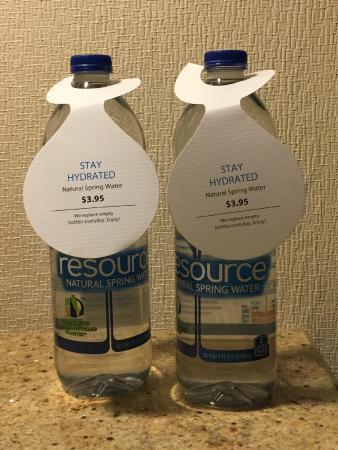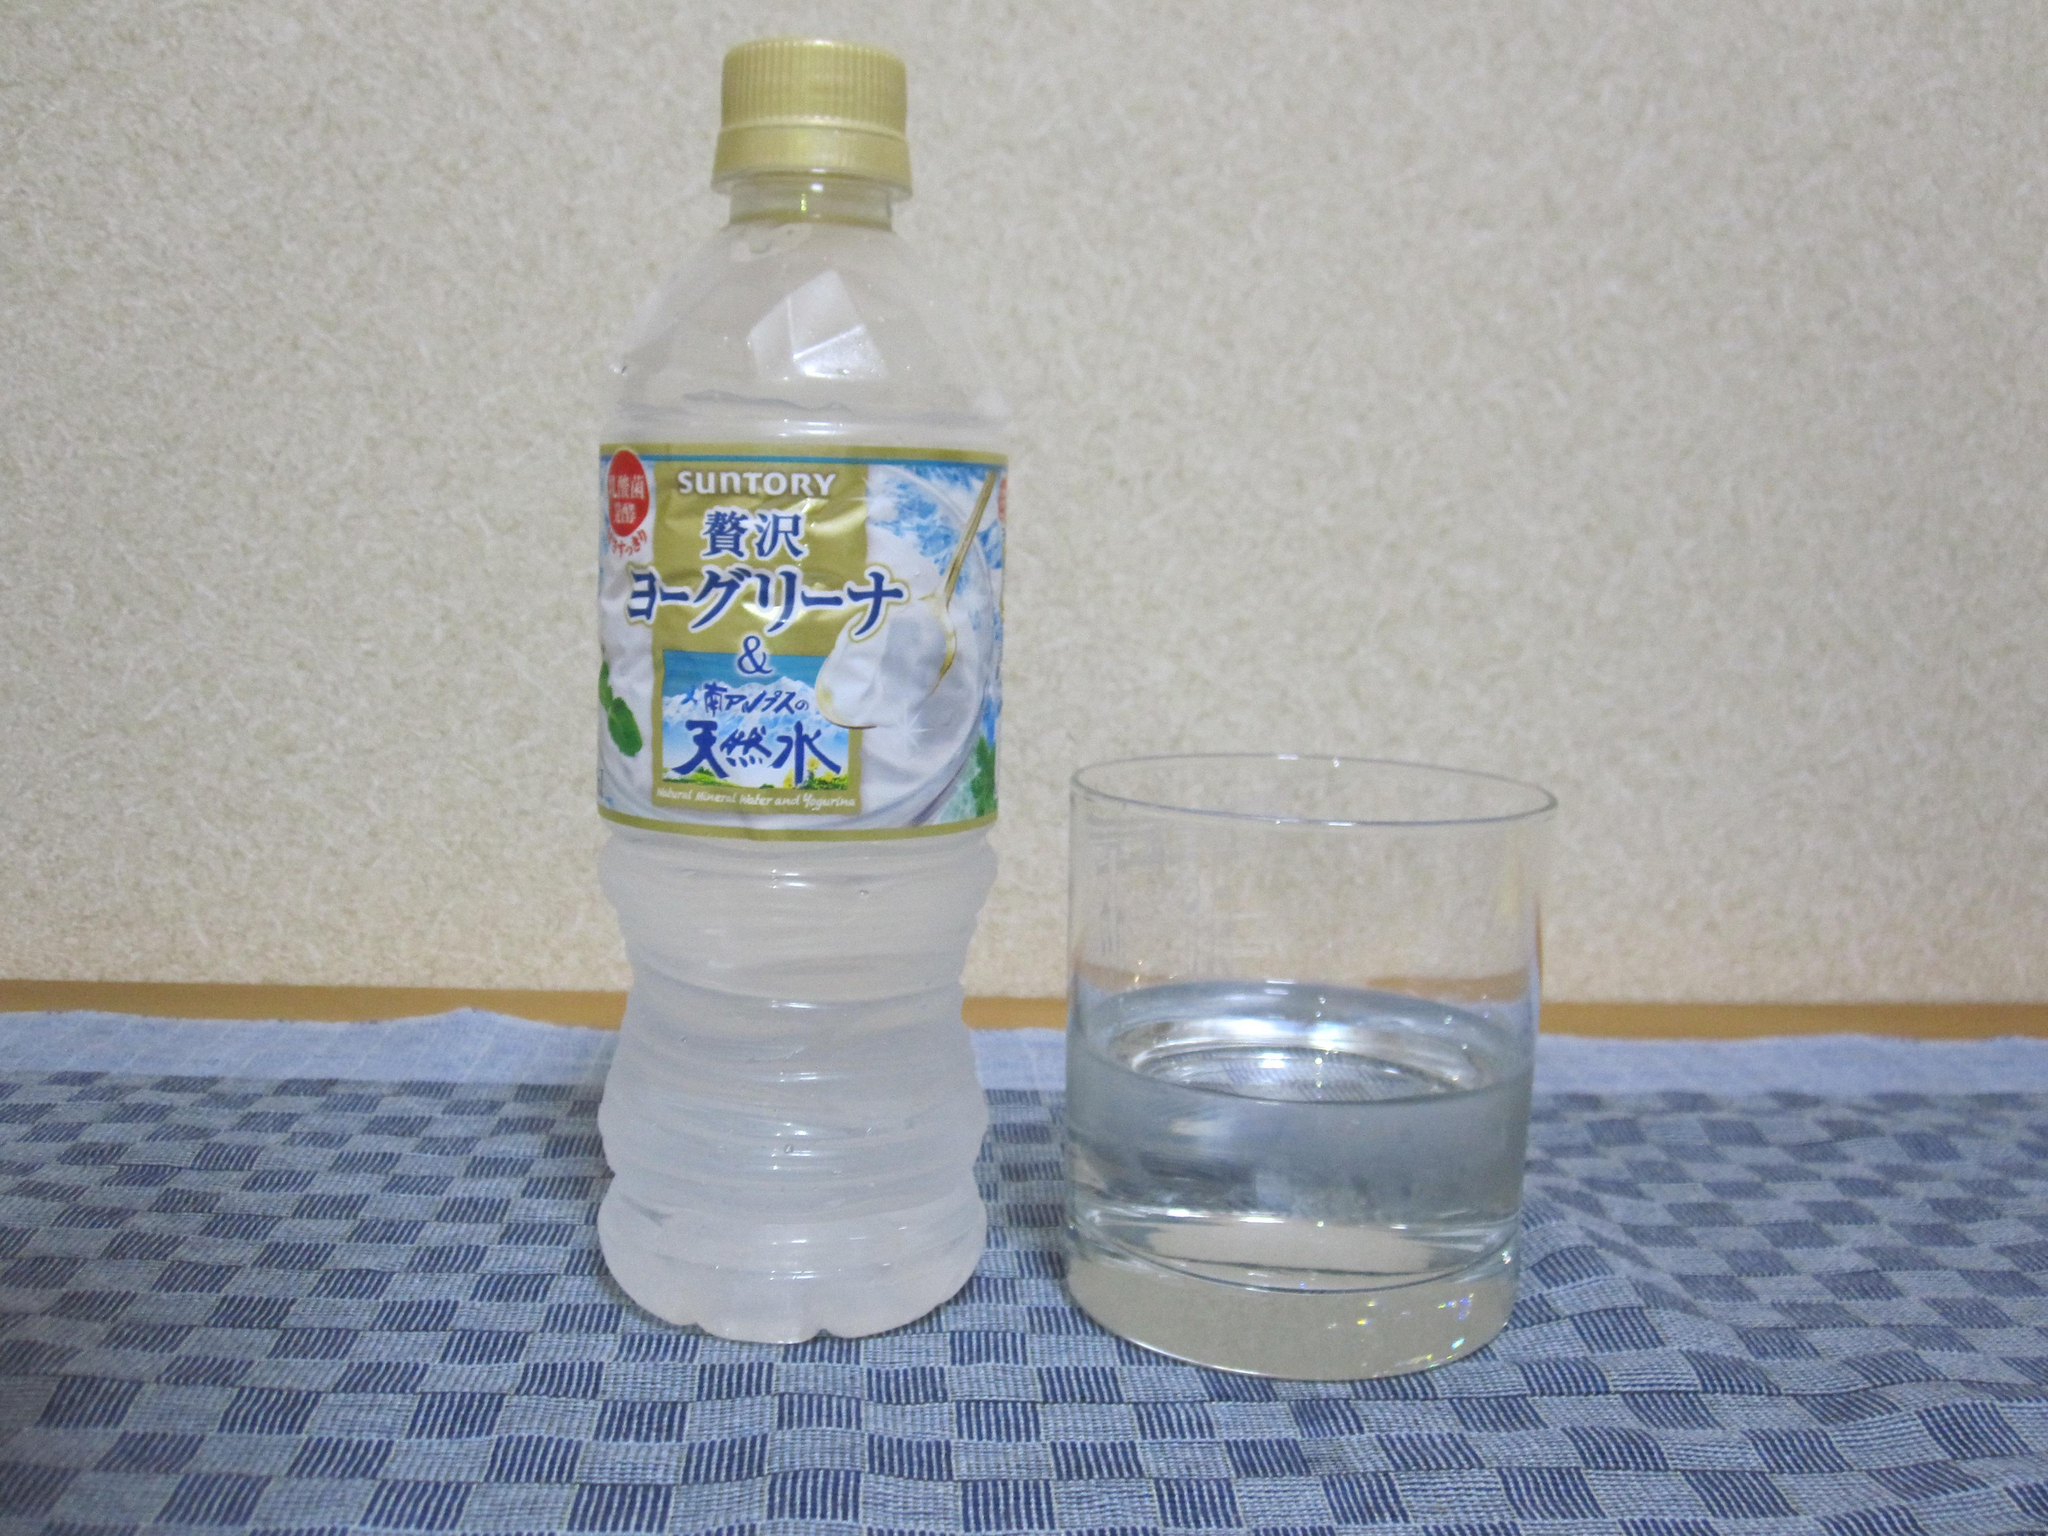The first image is the image on the left, the second image is the image on the right. For the images displayed, is the sentence "The right and left images include the same number of water containers." factually correct? Answer yes or no. Yes. The first image is the image on the left, the second image is the image on the right. Given the left and right images, does the statement "The left and right image contains the same number of containers filled with water." hold true? Answer yes or no. Yes. 